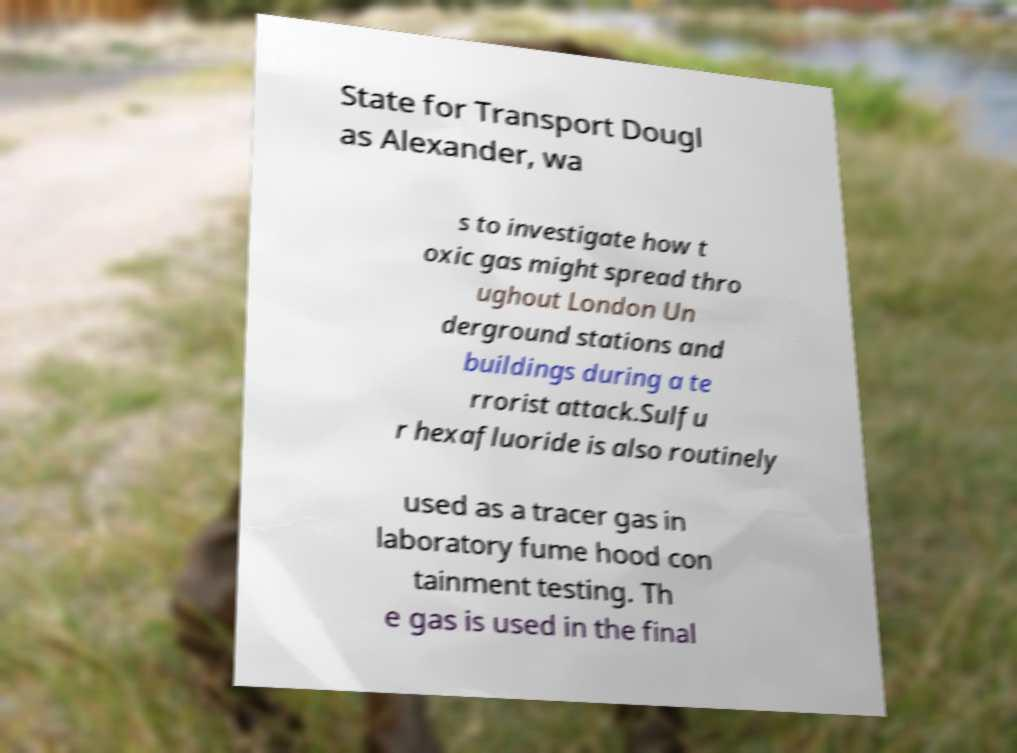Can you read and provide the text displayed in the image?This photo seems to have some interesting text. Can you extract and type it out for me? State for Transport Dougl as Alexander, wa s to investigate how t oxic gas might spread thro ughout London Un derground stations and buildings during a te rrorist attack.Sulfu r hexafluoride is also routinely used as a tracer gas in laboratory fume hood con tainment testing. Th e gas is used in the final 